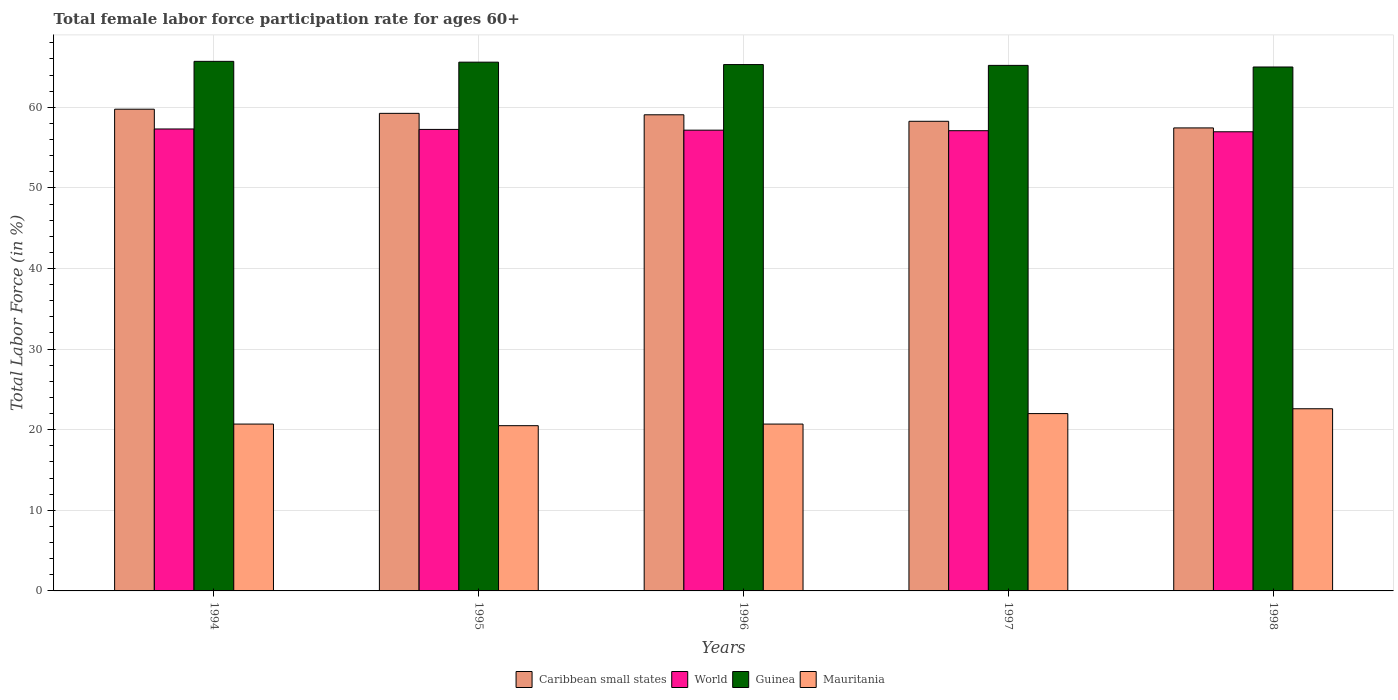Are the number of bars per tick equal to the number of legend labels?
Your answer should be compact. Yes. In how many cases, is the number of bars for a given year not equal to the number of legend labels?
Ensure brevity in your answer.  0. What is the female labor force participation rate in Mauritania in 1995?
Provide a succinct answer. 20.5. Across all years, what is the maximum female labor force participation rate in World?
Your answer should be very brief. 57.31. Across all years, what is the minimum female labor force participation rate in Mauritania?
Ensure brevity in your answer.  20.5. In which year was the female labor force participation rate in World maximum?
Your answer should be very brief. 1994. What is the total female labor force participation rate in World in the graph?
Make the answer very short. 285.79. What is the difference between the female labor force participation rate in Mauritania in 1996 and that in 1998?
Make the answer very short. -1.9. What is the difference between the female labor force participation rate in Caribbean small states in 1994 and the female labor force participation rate in World in 1995?
Your answer should be compact. 2.51. What is the average female labor force participation rate in Caribbean small states per year?
Make the answer very short. 58.76. In the year 1998, what is the difference between the female labor force participation rate in World and female labor force participation rate in Guinea?
Keep it short and to the point. -8.04. In how many years, is the female labor force participation rate in Guinea greater than 6 %?
Keep it short and to the point. 5. What is the ratio of the female labor force participation rate in Caribbean small states in 1994 to that in 1997?
Ensure brevity in your answer.  1.03. Is the female labor force participation rate in World in 1994 less than that in 1998?
Keep it short and to the point. No. Is the difference between the female labor force participation rate in World in 1995 and 1996 greater than the difference between the female labor force participation rate in Guinea in 1995 and 1996?
Make the answer very short. No. What is the difference between the highest and the second highest female labor force participation rate in Guinea?
Ensure brevity in your answer.  0.1. What is the difference between the highest and the lowest female labor force participation rate in World?
Keep it short and to the point. 0.35. Is the sum of the female labor force participation rate in Caribbean small states in 1995 and 1996 greater than the maximum female labor force participation rate in Mauritania across all years?
Give a very brief answer. Yes. What does the 1st bar from the left in 1998 represents?
Provide a succinct answer. Caribbean small states. What does the 4th bar from the right in 1995 represents?
Your response must be concise. Caribbean small states. Are all the bars in the graph horizontal?
Provide a succinct answer. No. How many years are there in the graph?
Your response must be concise. 5. Does the graph contain any zero values?
Ensure brevity in your answer.  No. Where does the legend appear in the graph?
Provide a succinct answer. Bottom center. How many legend labels are there?
Provide a succinct answer. 4. What is the title of the graph?
Provide a succinct answer. Total female labor force participation rate for ages 60+. Does "Sierra Leone" appear as one of the legend labels in the graph?
Ensure brevity in your answer.  No. What is the Total Labor Force (in %) in Caribbean small states in 1994?
Give a very brief answer. 59.76. What is the Total Labor Force (in %) of World in 1994?
Ensure brevity in your answer.  57.31. What is the Total Labor Force (in %) of Guinea in 1994?
Offer a very short reply. 65.7. What is the Total Labor Force (in %) of Mauritania in 1994?
Keep it short and to the point. 20.7. What is the Total Labor Force (in %) of Caribbean small states in 1995?
Your response must be concise. 59.25. What is the Total Labor Force (in %) in World in 1995?
Provide a succinct answer. 57.26. What is the Total Labor Force (in %) of Guinea in 1995?
Your response must be concise. 65.6. What is the Total Labor Force (in %) in Mauritania in 1995?
Keep it short and to the point. 20.5. What is the Total Labor Force (in %) of Caribbean small states in 1996?
Keep it short and to the point. 59.07. What is the Total Labor Force (in %) in World in 1996?
Make the answer very short. 57.16. What is the Total Labor Force (in %) of Guinea in 1996?
Your answer should be compact. 65.3. What is the Total Labor Force (in %) in Mauritania in 1996?
Your answer should be very brief. 20.7. What is the Total Labor Force (in %) in Caribbean small states in 1997?
Offer a very short reply. 58.26. What is the Total Labor Force (in %) in World in 1997?
Provide a succinct answer. 57.1. What is the Total Labor Force (in %) in Guinea in 1997?
Your response must be concise. 65.2. What is the Total Labor Force (in %) in Caribbean small states in 1998?
Give a very brief answer. 57.44. What is the Total Labor Force (in %) in World in 1998?
Make the answer very short. 56.96. What is the Total Labor Force (in %) of Guinea in 1998?
Provide a succinct answer. 65. What is the Total Labor Force (in %) of Mauritania in 1998?
Offer a terse response. 22.6. Across all years, what is the maximum Total Labor Force (in %) in Caribbean small states?
Keep it short and to the point. 59.76. Across all years, what is the maximum Total Labor Force (in %) in World?
Make the answer very short. 57.31. Across all years, what is the maximum Total Labor Force (in %) of Guinea?
Offer a terse response. 65.7. Across all years, what is the maximum Total Labor Force (in %) of Mauritania?
Offer a terse response. 22.6. Across all years, what is the minimum Total Labor Force (in %) in Caribbean small states?
Your answer should be very brief. 57.44. Across all years, what is the minimum Total Labor Force (in %) in World?
Your answer should be compact. 56.96. What is the total Total Labor Force (in %) of Caribbean small states in the graph?
Offer a terse response. 293.79. What is the total Total Labor Force (in %) in World in the graph?
Your answer should be very brief. 285.79. What is the total Total Labor Force (in %) of Guinea in the graph?
Ensure brevity in your answer.  326.8. What is the total Total Labor Force (in %) in Mauritania in the graph?
Make the answer very short. 106.5. What is the difference between the Total Labor Force (in %) in Caribbean small states in 1994 and that in 1995?
Provide a short and direct response. 0.51. What is the difference between the Total Labor Force (in %) in World in 1994 and that in 1995?
Your answer should be compact. 0.05. What is the difference between the Total Labor Force (in %) in Caribbean small states in 1994 and that in 1996?
Provide a short and direct response. 0.69. What is the difference between the Total Labor Force (in %) in World in 1994 and that in 1996?
Provide a succinct answer. 0.15. What is the difference between the Total Labor Force (in %) of Caribbean small states in 1994 and that in 1997?
Give a very brief answer. 1.5. What is the difference between the Total Labor Force (in %) in World in 1994 and that in 1997?
Your answer should be very brief. 0.21. What is the difference between the Total Labor Force (in %) of Mauritania in 1994 and that in 1997?
Your response must be concise. -1.3. What is the difference between the Total Labor Force (in %) in Caribbean small states in 1994 and that in 1998?
Your answer should be compact. 2.32. What is the difference between the Total Labor Force (in %) in World in 1994 and that in 1998?
Provide a succinct answer. 0.35. What is the difference between the Total Labor Force (in %) in Caribbean small states in 1995 and that in 1996?
Make the answer very short. 0.18. What is the difference between the Total Labor Force (in %) in World in 1995 and that in 1996?
Ensure brevity in your answer.  0.09. What is the difference between the Total Labor Force (in %) of Mauritania in 1995 and that in 1996?
Ensure brevity in your answer.  -0.2. What is the difference between the Total Labor Force (in %) in Caribbean small states in 1995 and that in 1997?
Your response must be concise. 0.99. What is the difference between the Total Labor Force (in %) of World in 1995 and that in 1997?
Offer a terse response. 0.16. What is the difference between the Total Labor Force (in %) of Guinea in 1995 and that in 1997?
Offer a very short reply. 0.4. What is the difference between the Total Labor Force (in %) in Mauritania in 1995 and that in 1997?
Provide a short and direct response. -1.5. What is the difference between the Total Labor Force (in %) in Caribbean small states in 1995 and that in 1998?
Offer a terse response. 1.81. What is the difference between the Total Labor Force (in %) of World in 1995 and that in 1998?
Give a very brief answer. 0.29. What is the difference between the Total Labor Force (in %) of Mauritania in 1995 and that in 1998?
Offer a terse response. -2.1. What is the difference between the Total Labor Force (in %) in Caribbean small states in 1996 and that in 1997?
Provide a succinct answer. 0.81. What is the difference between the Total Labor Force (in %) in World in 1996 and that in 1997?
Your response must be concise. 0.07. What is the difference between the Total Labor Force (in %) in Guinea in 1996 and that in 1997?
Make the answer very short. 0.1. What is the difference between the Total Labor Force (in %) of Mauritania in 1996 and that in 1997?
Offer a very short reply. -1.3. What is the difference between the Total Labor Force (in %) in Caribbean small states in 1996 and that in 1998?
Offer a terse response. 1.63. What is the difference between the Total Labor Force (in %) in World in 1996 and that in 1998?
Offer a terse response. 0.2. What is the difference between the Total Labor Force (in %) of Guinea in 1996 and that in 1998?
Your answer should be compact. 0.3. What is the difference between the Total Labor Force (in %) in Caribbean small states in 1997 and that in 1998?
Provide a succinct answer. 0.82. What is the difference between the Total Labor Force (in %) in World in 1997 and that in 1998?
Provide a succinct answer. 0.13. What is the difference between the Total Labor Force (in %) of Mauritania in 1997 and that in 1998?
Your answer should be compact. -0.6. What is the difference between the Total Labor Force (in %) of Caribbean small states in 1994 and the Total Labor Force (in %) of World in 1995?
Your response must be concise. 2.51. What is the difference between the Total Labor Force (in %) in Caribbean small states in 1994 and the Total Labor Force (in %) in Guinea in 1995?
Provide a succinct answer. -5.84. What is the difference between the Total Labor Force (in %) in Caribbean small states in 1994 and the Total Labor Force (in %) in Mauritania in 1995?
Provide a succinct answer. 39.26. What is the difference between the Total Labor Force (in %) in World in 1994 and the Total Labor Force (in %) in Guinea in 1995?
Make the answer very short. -8.29. What is the difference between the Total Labor Force (in %) in World in 1994 and the Total Labor Force (in %) in Mauritania in 1995?
Give a very brief answer. 36.81. What is the difference between the Total Labor Force (in %) in Guinea in 1994 and the Total Labor Force (in %) in Mauritania in 1995?
Provide a succinct answer. 45.2. What is the difference between the Total Labor Force (in %) of Caribbean small states in 1994 and the Total Labor Force (in %) of World in 1996?
Ensure brevity in your answer.  2.6. What is the difference between the Total Labor Force (in %) in Caribbean small states in 1994 and the Total Labor Force (in %) in Guinea in 1996?
Make the answer very short. -5.54. What is the difference between the Total Labor Force (in %) of Caribbean small states in 1994 and the Total Labor Force (in %) of Mauritania in 1996?
Your answer should be very brief. 39.06. What is the difference between the Total Labor Force (in %) in World in 1994 and the Total Labor Force (in %) in Guinea in 1996?
Provide a short and direct response. -7.99. What is the difference between the Total Labor Force (in %) in World in 1994 and the Total Labor Force (in %) in Mauritania in 1996?
Provide a short and direct response. 36.61. What is the difference between the Total Labor Force (in %) of Guinea in 1994 and the Total Labor Force (in %) of Mauritania in 1996?
Keep it short and to the point. 45. What is the difference between the Total Labor Force (in %) of Caribbean small states in 1994 and the Total Labor Force (in %) of World in 1997?
Make the answer very short. 2.67. What is the difference between the Total Labor Force (in %) of Caribbean small states in 1994 and the Total Labor Force (in %) of Guinea in 1997?
Your response must be concise. -5.44. What is the difference between the Total Labor Force (in %) of Caribbean small states in 1994 and the Total Labor Force (in %) of Mauritania in 1997?
Your answer should be compact. 37.76. What is the difference between the Total Labor Force (in %) of World in 1994 and the Total Labor Force (in %) of Guinea in 1997?
Make the answer very short. -7.89. What is the difference between the Total Labor Force (in %) in World in 1994 and the Total Labor Force (in %) in Mauritania in 1997?
Provide a short and direct response. 35.31. What is the difference between the Total Labor Force (in %) of Guinea in 1994 and the Total Labor Force (in %) of Mauritania in 1997?
Offer a terse response. 43.7. What is the difference between the Total Labor Force (in %) of Caribbean small states in 1994 and the Total Labor Force (in %) of World in 1998?
Ensure brevity in your answer.  2.8. What is the difference between the Total Labor Force (in %) in Caribbean small states in 1994 and the Total Labor Force (in %) in Guinea in 1998?
Offer a terse response. -5.24. What is the difference between the Total Labor Force (in %) in Caribbean small states in 1994 and the Total Labor Force (in %) in Mauritania in 1998?
Provide a short and direct response. 37.16. What is the difference between the Total Labor Force (in %) in World in 1994 and the Total Labor Force (in %) in Guinea in 1998?
Your response must be concise. -7.69. What is the difference between the Total Labor Force (in %) in World in 1994 and the Total Labor Force (in %) in Mauritania in 1998?
Your answer should be very brief. 34.71. What is the difference between the Total Labor Force (in %) in Guinea in 1994 and the Total Labor Force (in %) in Mauritania in 1998?
Keep it short and to the point. 43.1. What is the difference between the Total Labor Force (in %) of Caribbean small states in 1995 and the Total Labor Force (in %) of World in 1996?
Your answer should be very brief. 2.09. What is the difference between the Total Labor Force (in %) of Caribbean small states in 1995 and the Total Labor Force (in %) of Guinea in 1996?
Your answer should be compact. -6.05. What is the difference between the Total Labor Force (in %) in Caribbean small states in 1995 and the Total Labor Force (in %) in Mauritania in 1996?
Give a very brief answer. 38.55. What is the difference between the Total Labor Force (in %) in World in 1995 and the Total Labor Force (in %) in Guinea in 1996?
Offer a very short reply. -8.04. What is the difference between the Total Labor Force (in %) in World in 1995 and the Total Labor Force (in %) in Mauritania in 1996?
Your response must be concise. 36.56. What is the difference between the Total Labor Force (in %) in Guinea in 1995 and the Total Labor Force (in %) in Mauritania in 1996?
Your response must be concise. 44.9. What is the difference between the Total Labor Force (in %) of Caribbean small states in 1995 and the Total Labor Force (in %) of World in 1997?
Your answer should be compact. 2.15. What is the difference between the Total Labor Force (in %) in Caribbean small states in 1995 and the Total Labor Force (in %) in Guinea in 1997?
Your answer should be compact. -5.95. What is the difference between the Total Labor Force (in %) in Caribbean small states in 1995 and the Total Labor Force (in %) in Mauritania in 1997?
Ensure brevity in your answer.  37.25. What is the difference between the Total Labor Force (in %) in World in 1995 and the Total Labor Force (in %) in Guinea in 1997?
Your answer should be compact. -7.94. What is the difference between the Total Labor Force (in %) of World in 1995 and the Total Labor Force (in %) of Mauritania in 1997?
Your response must be concise. 35.26. What is the difference between the Total Labor Force (in %) in Guinea in 1995 and the Total Labor Force (in %) in Mauritania in 1997?
Keep it short and to the point. 43.6. What is the difference between the Total Labor Force (in %) in Caribbean small states in 1995 and the Total Labor Force (in %) in World in 1998?
Offer a very short reply. 2.29. What is the difference between the Total Labor Force (in %) of Caribbean small states in 1995 and the Total Labor Force (in %) of Guinea in 1998?
Your response must be concise. -5.75. What is the difference between the Total Labor Force (in %) of Caribbean small states in 1995 and the Total Labor Force (in %) of Mauritania in 1998?
Ensure brevity in your answer.  36.65. What is the difference between the Total Labor Force (in %) in World in 1995 and the Total Labor Force (in %) in Guinea in 1998?
Provide a succinct answer. -7.74. What is the difference between the Total Labor Force (in %) in World in 1995 and the Total Labor Force (in %) in Mauritania in 1998?
Give a very brief answer. 34.66. What is the difference between the Total Labor Force (in %) in Guinea in 1995 and the Total Labor Force (in %) in Mauritania in 1998?
Your answer should be compact. 43. What is the difference between the Total Labor Force (in %) in Caribbean small states in 1996 and the Total Labor Force (in %) in World in 1997?
Make the answer very short. 1.97. What is the difference between the Total Labor Force (in %) in Caribbean small states in 1996 and the Total Labor Force (in %) in Guinea in 1997?
Your answer should be very brief. -6.13. What is the difference between the Total Labor Force (in %) in Caribbean small states in 1996 and the Total Labor Force (in %) in Mauritania in 1997?
Offer a terse response. 37.07. What is the difference between the Total Labor Force (in %) of World in 1996 and the Total Labor Force (in %) of Guinea in 1997?
Your answer should be compact. -8.04. What is the difference between the Total Labor Force (in %) in World in 1996 and the Total Labor Force (in %) in Mauritania in 1997?
Keep it short and to the point. 35.16. What is the difference between the Total Labor Force (in %) in Guinea in 1996 and the Total Labor Force (in %) in Mauritania in 1997?
Keep it short and to the point. 43.3. What is the difference between the Total Labor Force (in %) in Caribbean small states in 1996 and the Total Labor Force (in %) in World in 1998?
Your answer should be very brief. 2.11. What is the difference between the Total Labor Force (in %) of Caribbean small states in 1996 and the Total Labor Force (in %) of Guinea in 1998?
Your response must be concise. -5.93. What is the difference between the Total Labor Force (in %) of Caribbean small states in 1996 and the Total Labor Force (in %) of Mauritania in 1998?
Ensure brevity in your answer.  36.47. What is the difference between the Total Labor Force (in %) of World in 1996 and the Total Labor Force (in %) of Guinea in 1998?
Provide a short and direct response. -7.84. What is the difference between the Total Labor Force (in %) of World in 1996 and the Total Labor Force (in %) of Mauritania in 1998?
Offer a very short reply. 34.56. What is the difference between the Total Labor Force (in %) in Guinea in 1996 and the Total Labor Force (in %) in Mauritania in 1998?
Your answer should be very brief. 42.7. What is the difference between the Total Labor Force (in %) of Caribbean small states in 1997 and the Total Labor Force (in %) of World in 1998?
Provide a succinct answer. 1.3. What is the difference between the Total Labor Force (in %) in Caribbean small states in 1997 and the Total Labor Force (in %) in Guinea in 1998?
Make the answer very short. -6.74. What is the difference between the Total Labor Force (in %) of Caribbean small states in 1997 and the Total Labor Force (in %) of Mauritania in 1998?
Give a very brief answer. 35.66. What is the difference between the Total Labor Force (in %) of World in 1997 and the Total Labor Force (in %) of Guinea in 1998?
Ensure brevity in your answer.  -7.9. What is the difference between the Total Labor Force (in %) of World in 1997 and the Total Labor Force (in %) of Mauritania in 1998?
Offer a terse response. 34.5. What is the difference between the Total Labor Force (in %) of Guinea in 1997 and the Total Labor Force (in %) of Mauritania in 1998?
Keep it short and to the point. 42.6. What is the average Total Labor Force (in %) of Caribbean small states per year?
Your answer should be very brief. 58.76. What is the average Total Labor Force (in %) in World per year?
Give a very brief answer. 57.16. What is the average Total Labor Force (in %) in Guinea per year?
Provide a short and direct response. 65.36. What is the average Total Labor Force (in %) in Mauritania per year?
Give a very brief answer. 21.3. In the year 1994, what is the difference between the Total Labor Force (in %) in Caribbean small states and Total Labor Force (in %) in World?
Offer a very short reply. 2.45. In the year 1994, what is the difference between the Total Labor Force (in %) in Caribbean small states and Total Labor Force (in %) in Guinea?
Your response must be concise. -5.94. In the year 1994, what is the difference between the Total Labor Force (in %) of Caribbean small states and Total Labor Force (in %) of Mauritania?
Provide a succinct answer. 39.06. In the year 1994, what is the difference between the Total Labor Force (in %) in World and Total Labor Force (in %) in Guinea?
Give a very brief answer. -8.39. In the year 1994, what is the difference between the Total Labor Force (in %) in World and Total Labor Force (in %) in Mauritania?
Your answer should be compact. 36.61. In the year 1994, what is the difference between the Total Labor Force (in %) of Guinea and Total Labor Force (in %) of Mauritania?
Ensure brevity in your answer.  45. In the year 1995, what is the difference between the Total Labor Force (in %) of Caribbean small states and Total Labor Force (in %) of World?
Ensure brevity in your answer.  1.99. In the year 1995, what is the difference between the Total Labor Force (in %) in Caribbean small states and Total Labor Force (in %) in Guinea?
Your response must be concise. -6.35. In the year 1995, what is the difference between the Total Labor Force (in %) of Caribbean small states and Total Labor Force (in %) of Mauritania?
Make the answer very short. 38.75. In the year 1995, what is the difference between the Total Labor Force (in %) in World and Total Labor Force (in %) in Guinea?
Offer a terse response. -8.34. In the year 1995, what is the difference between the Total Labor Force (in %) in World and Total Labor Force (in %) in Mauritania?
Your answer should be compact. 36.76. In the year 1995, what is the difference between the Total Labor Force (in %) in Guinea and Total Labor Force (in %) in Mauritania?
Give a very brief answer. 45.1. In the year 1996, what is the difference between the Total Labor Force (in %) in Caribbean small states and Total Labor Force (in %) in World?
Your answer should be very brief. 1.91. In the year 1996, what is the difference between the Total Labor Force (in %) in Caribbean small states and Total Labor Force (in %) in Guinea?
Your answer should be compact. -6.23. In the year 1996, what is the difference between the Total Labor Force (in %) in Caribbean small states and Total Labor Force (in %) in Mauritania?
Provide a short and direct response. 38.37. In the year 1996, what is the difference between the Total Labor Force (in %) of World and Total Labor Force (in %) of Guinea?
Offer a very short reply. -8.14. In the year 1996, what is the difference between the Total Labor Force (in %) of World and Total Labor Force (in %) of Mauritania?
Your answer should be compact. 36.46. In the year 1996, what is the difference between the Total Labor Force (in %) of Guinea and Total Labor Force (in %) of Mauritania?
Make the answer very short. 44.6. In the year 1997, what is the difference between the Total Labor Force (in %) in Caribbean small states and Total Labor Force (in %) in World?
Provide a succinct answer. 1.17. In the year 1997, what is the difference between the Total Labor Force (in %) in Caribbean small states and Total Labor Force (in %) in Guinea?
Offer a very short reply. -6.94. In the year 1997, what is the difference between the Total Labor Force (in %) of Caribbean small states and Total Labor Force (in %) of Mauritania?
Provide a short and direct response. 36.26. In the year 1997, what is the difference between the Total Labor Force (in %) of World and Total Labor Force (in %) of Guinea?
Your answer should be very brief. -8.1. In the year 1997, what is the difference between the Total Labor Force (in %) of World and Total Labor Force (in %) of Mauritania?
Offer a very short reply. 35.1. In the year 1997, what is the difference between the Total Labor Force (in %) of Guinea and Total Labor Force (in %) of Mauritania?
Provide a short and direct response. 43.2. In the year 1998, what is the difference between the Total Labor Force (in %) of Caribbean small states and Total Labor Force (in %) of World?
Your response must be concise. 0.48. In the year 1998, what is the difference between the Total Labor Force (in %) in Caribbean small states and Total Labor Force (in %) in Guinea?
Offer a very short reply. -7.56. In the year 1998, what is the difference between the Total Labor Force (in %) of Caribbean small states and Total Labor Force (in %) of Mauritania?
Provide a succinct answer. 34.84. In the year 1998, what is the difference between the Total Labor Force (in %) in World and Total Labor Force (in %) in Guinea?
Offer a terse response. -8.04. In the year 1998, what is the difference between the Total Labor Force (in %) in World and Total Labor Force (in %) in Mauritania?
Keep it short and to the point. 34.36. In the year 1998, what is the difference between the Total Labor Force (in %) of Guinea and Total Labor Force (in %) of Mauritania?
Your response must be concise. 42.4. What is the ratio of the Total Labor Force (in %) of Caribbean small states in 1994 to that in 1995?
Offer a terse response. 1.01. What is the ratio of the Total Labor Force (in %) of Mauritania in 1994 to that in 1995?
Your answer should be very brief. 1.01. What is the ratio of the Total Labor Force (in %) in Caribbean small states in 1994 to that in 1996?
Make the answer very short. 1.01. What is the ratio of the Total Labor Force (in %) in Guinea in 1994 to that in 1996?
Your response must be concise. 1.01. What is the ratio of the Total Labor Force (in %) of Caribbean small states in 1994 to that in 1997?
Keep it short and to the point. 1.03. What is the ratio of the Total Labor Force (in %) of Guinea in 1994 to that in 1997?
Provide a succinct answer. 1.01. What is the ratio of the Total Labor Force (in %) of Mauritania in 1994 to that in 1997?
Offer a terse response. 0.94. What is the ratio of the Total Labor Force (in %) in Caribbean small states in 1994 to that in 1998?
Make the answer very short. 1.04. What is the ratio of the Total Labor Force (in %) in World in 1994 to that in 1998?
Provide a short and direct response. 1.01. What is the ratio of the Total Labor Force (in %) in Guinea in 1994 to that in 1998?
Your answer should be compact. 1.01. What is the ratio of the Total Labor Force (in %) in Mauritania in 1994 to that in 1998?
Your answer should be very brief. 0.92. What is the ratio of the Total Labor Force (in %) in Caribbean small states in 1995 to that in 1996?
Provide a short and direct response. 1. What is the ratio of the Total Labor Force (in %) in World in 1995 to that in 1996?
Provide a short and direct response. 1. What is the ratio of the Total Labor Force (in %) in Mauritania in 1995 to that in 1996?
Provide a short and direct response. 0.99. What is the ratio of the Total Labor Force (in %) in Caribbean small states in 1995 to that in 1997?
Ensure brevity in your answer.  1.02. What is the ratio of the Total Labor Force (in %) of World in 1995 to that in 1997?
Make the answer very short. 1. What is the ratio of the Total Labor Force (in %) in Mauritania in 1995 to that in 1997?
Provide a short and direct response. 0.93. What is the ratio of the Total Labor Force (in %) in Caribbean small states in 1995 to that in 1998?
Ensure brevity in your answer.  1.03. What is the ratio of the Total Labor Force (in %) in World in 1995 to that in 1998?
Your answer should be very brief. 1.01. What is the ratio of the Total Labor Force (in %) of Guinea in 1995 to that in 1998?
Offer a very short reply. 1.01. What is the ratio of the Total Labor Force (in %) in Mauritania in 1995 to that in 1998?
Ensure brevity in your answer.  0.91. What is the ratio of the Total Labor Force (in %) in Caribbean small states in 1996 to that in 1997?
Make the answer very short. 1.01. What is the ratio of the Total Labor Force (in %) of World in 1996 to that in 1997?
Your answer should be compact. 1. What is the ratio of the Total Labor Force (in %) in Guinea in 1996 to that in 1997?
Give a very brief answer. 1. What is the ratio of the Total Labor Force (in %) of Mauritania in 1996 to that in 1997?
Your answer should be very brief. 0.94. What is the ratio of the Total Labor Force (in %) of Caribbean small states in 1996 to that in 1998?
Your answer should be very brief. 1.03. What is the ratio of the Total Labor Force (in %) of Mauritania in 1996 to that in 1998?
Offer a terse response. 0.92. What is the ratio of the Total Labor Force (in %) of Caribbean small states in 1997 to that in 1998?
Provide a short and direct response. 1.01. What is the ratio of the Total Labor Force (in %) in World in 1997 to that in 1998?
Offer a very short reply. 1. What is the ratio of the Total Labor Force (in %) of Mauritania in 1997 to that in 1998?
Keep it short and to the point. 0.97. What is the difference between the highest and the second highest Total Labor Force (in %) in Caribbean small states?
Provide a short and direct response. 0.51. What is the difference between the highest and the second highest Total Labor Force (in %) of World?
Offer a terse response. 0.05. What is the difference between the highest and the lowest Total Labor Force (in %) in Caribbean small states?
Offer a terse response. 2.32. What is the difference between the highest and the lowest Total Labor Force (in %) in World?
Offer a very short reply. 0.35. 